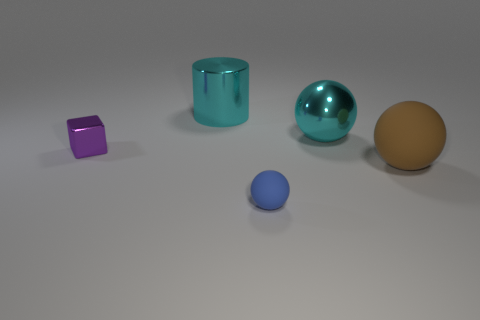There is a small shiny thing; does it have the same shape as the big thing in front of the small block?
Your response must be concise. No. There is a cyan object that is the same shape as the tiny blue thing; what is its size?
Provide a succinct answer. Large. There is a metal cylinder; is its color the same as the big sphere in front of the metal cube?
Provide a succinct answer. No. What number of other things are there of the same size as the purple shiny cube?
Give a very brief answer. 1. What shape is the big cyan metal thing to the right of the matte thing to the left of the rubber object right of the blue rubber thing?
Your response must be concise. Sphere. Is the size of the blue matte object the same as the ball that is behind the brown sphere?
Your answer should be very brief. No. There is a object that is behind the large matte ball and right of the big cylinder; what color is it?
Keep it short and to the point. Cyan. What number of other things are the same shape as the small blue rubber thing?
Your answer should be compact. 2. There is a tiny thing to the right of the purple metal cube; does it have the same color as the big metal thing that is in front of the large cyan metal cylinder?
Give a very brief answer. No. There is a sphere that is behind the small purple metal thing; does it have the same size as the thing that is left of the big cyan shiny cylinder?
Provide a short and direct response. No. 